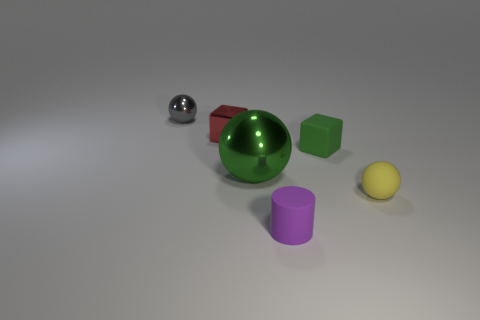Can you describe the lighting and mood of this scene? The lighting in the image seems to come from above, casting gentle shadows directly underneath the objects. The overall mood is quite neutral and appears to be for illustrative purposes, to display the objects rather than convey a specific emotion or atmosphere. 